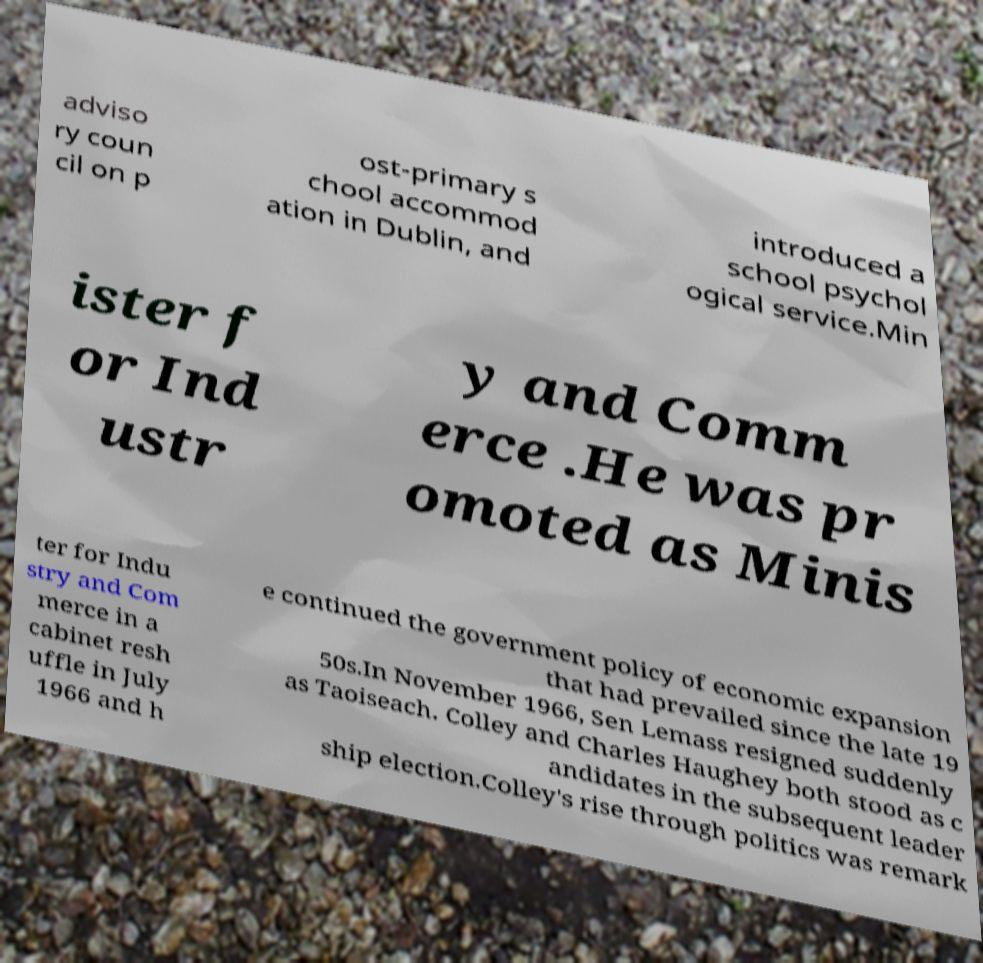Can you read and provide the text displayed in the image?This photo seems to have some interesting text. Can you extract and type it out for me? adviso ry coun cil on p ost-primary s chool accommod ation in Dublin, and introduced a school psychol ogical service.Min ister f or Ind ustr y and Comm erce .He was pr omoted as Minis ter for Indu stry and Com merce in a cabinet resh uffle in July 1966 and h e continued the government policy of economic expansion that had prevailed since the late 19 50s.In November 1966, Sen Lemass resigned suddenly as Taoiseach. Colley and Charles Haughey both stood as c andidates in the subsequent leader ship election.Colley's rise through politics was remark 